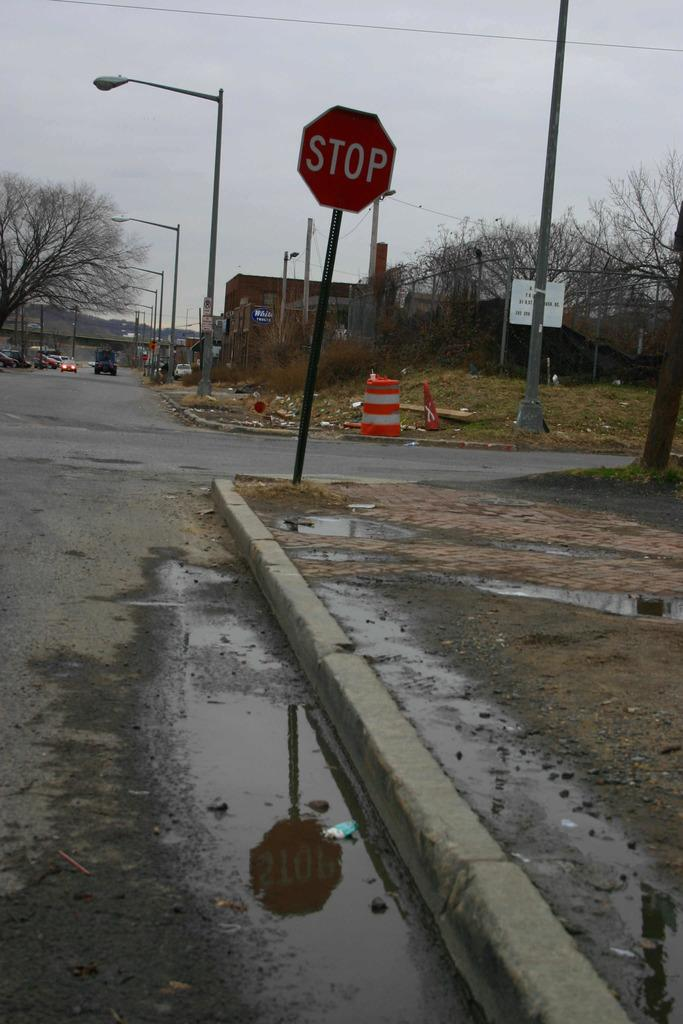Provide a one-sentence caption for the provided image. a bent STOP sign on a dirty urban street. 